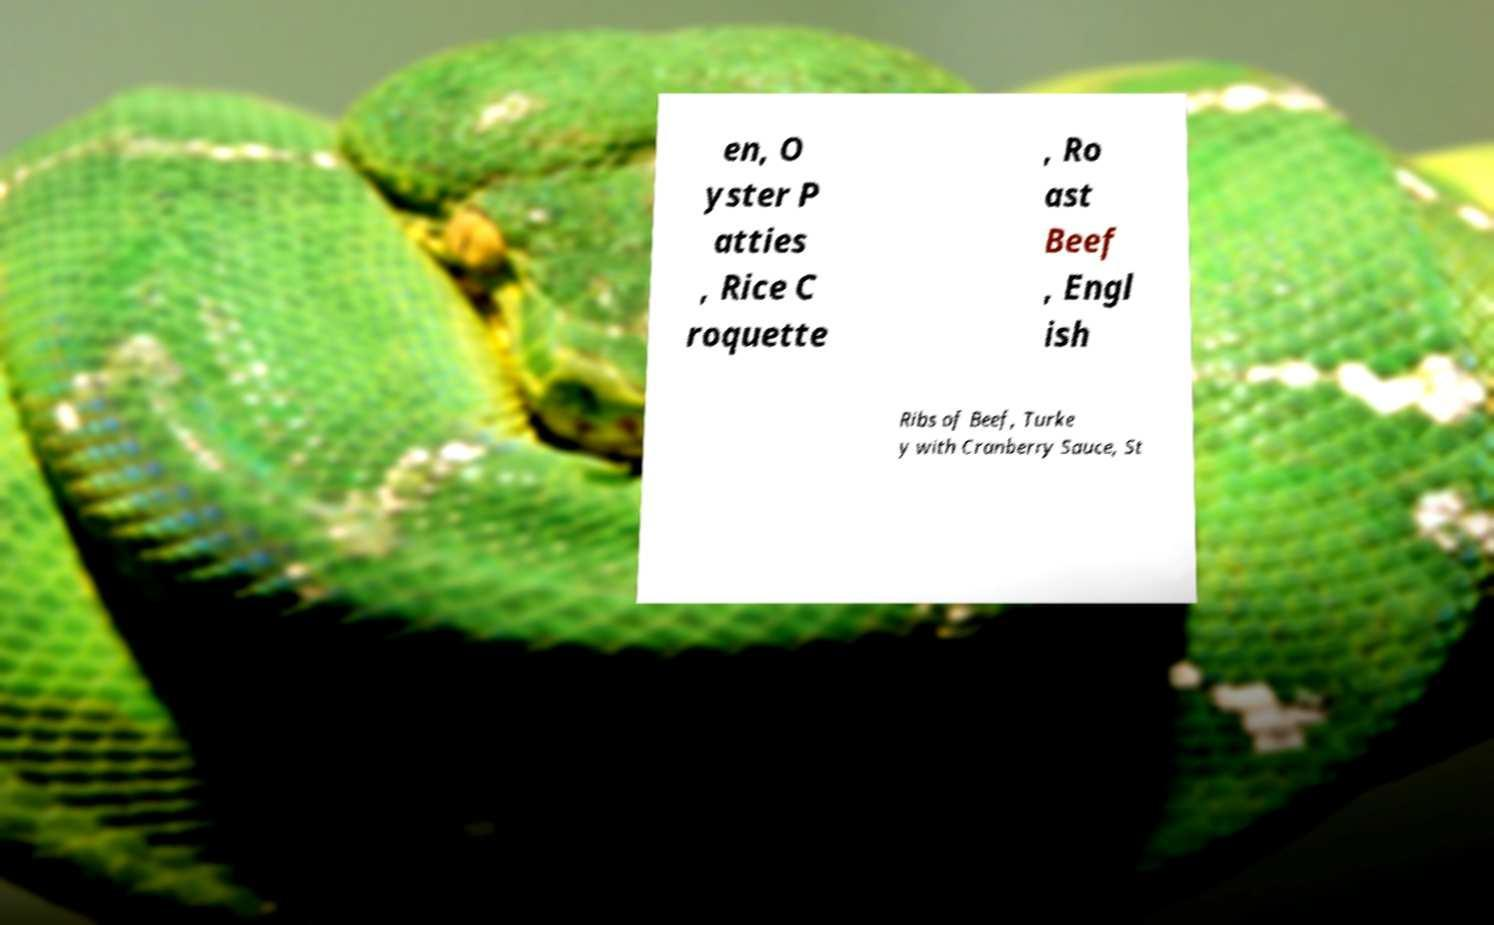There's text embedded in this image that I need extracted. Can you transcribe it verbatim? en, O yster P atties , Rice C roquette , Ro ast Beef , Engl ish Ribs of Beef, Turke y with Cranberry Sauce, St 